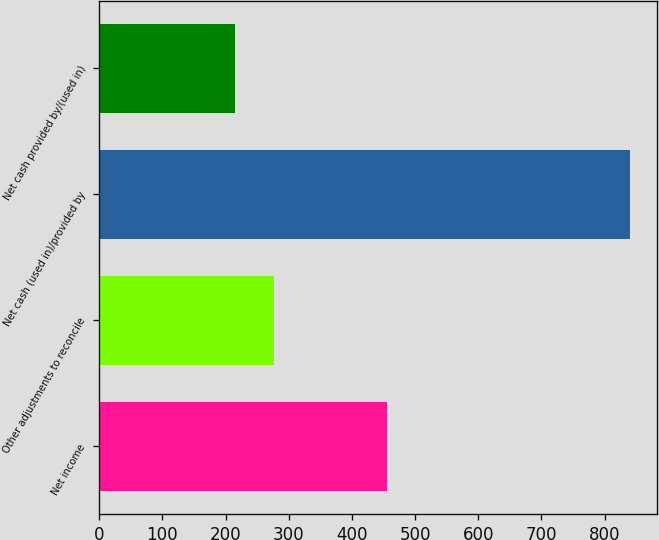Convert chart to OTSL. <chart><loc_0><loc_0><loc_500><loc_500><bar_chart><fcel>Net income<fcel>Other adjustments to reconcile<fcel>Net cash (used in)/provided by<fcel>Net cash provided by/(used in)<nl><fcel>456.1<fcel>276.87<fcel>840<fcel>214.3<nl></chart> 